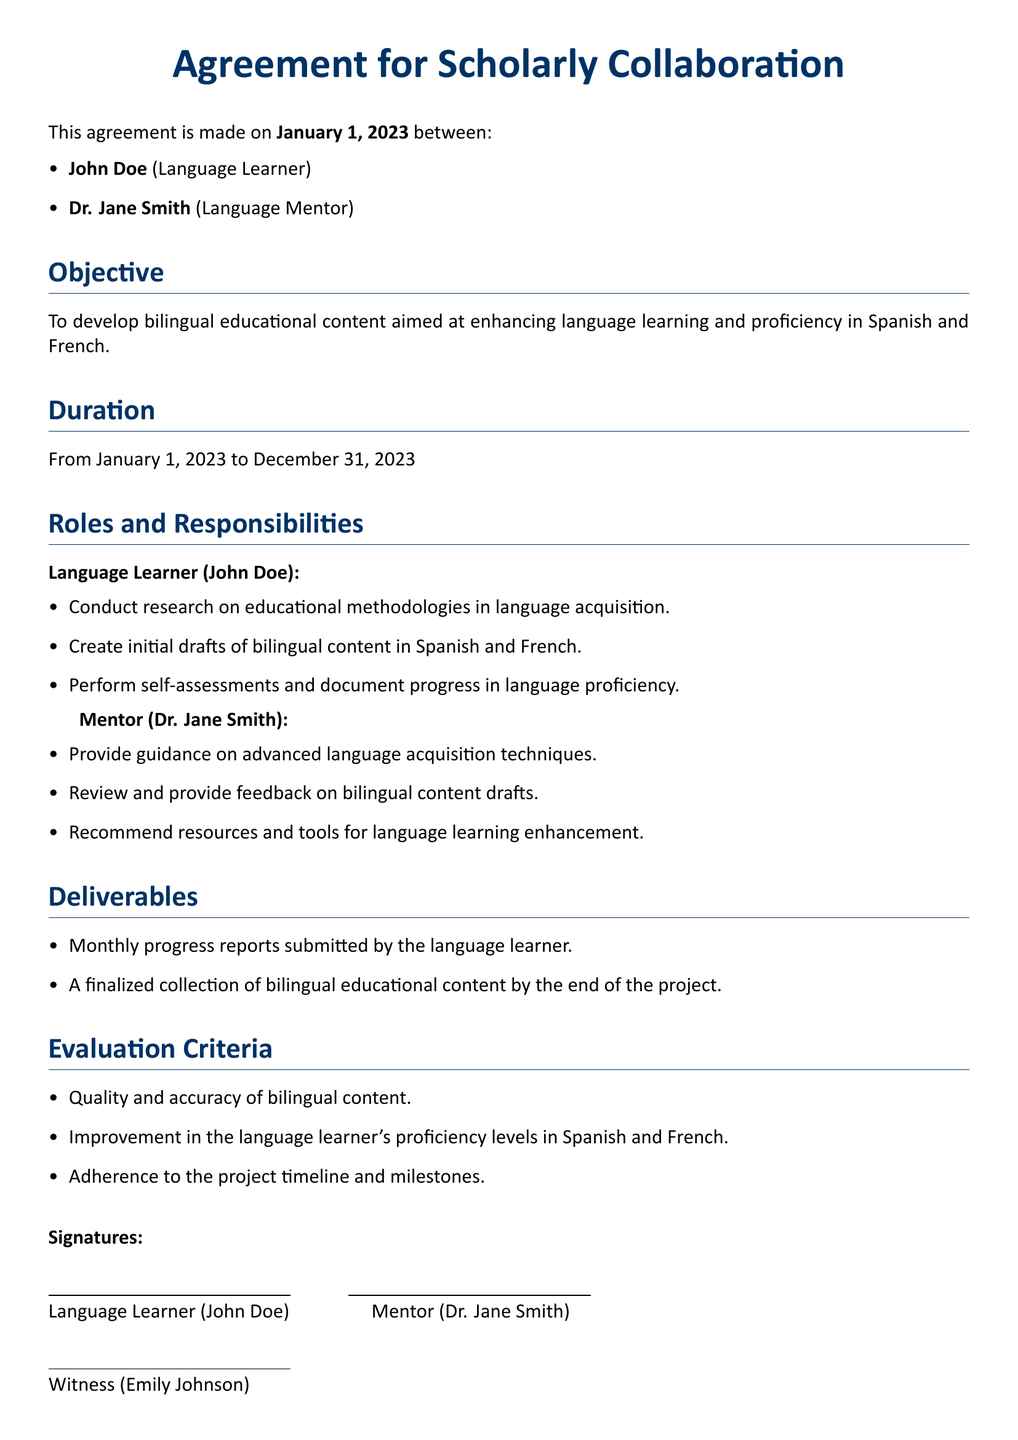What is the date the agreement was made? The date is clearly stated at the beginning of the document as January 1, 2023.
Answer: January 1, 2023 Who is the language mentor? The document lists Dr. Jane Smith as the language mentor in the introduction section.
Answer: Dr. Jane Smith What is the duration of the project? The duration is specified in the document, stating from January 1, 2023, to December 31, 2023.
Answer: January 1, 2023 to December 31, 2023 What is the primary objective of the agreement? The objective is stated explicitly as developing bilingual educational content aimed at enhancing language learning and proficiency in Spanish and French.
Answer: Developing bilingual educational content How many deliverables are mentioned? The document lists two deliverables that are specified in the Deliverables section.
Answer: Two What criteria is used for evaluation? The Evaluation Criteria section mentions three criteria for evaluation based on the quality and accuracy of content, improvement in proficiency levels, and adherence to the timeline.
Answer: Quality and accuracy of bilingual content Who is the witness? The witness is named at the end of the document, marking her involvement in the agreement.
Answer: Emily Johnson What is the role of the language learner? The document outlines specific responsibilities for the language learner, including conducting research and creating content drafts.
Answer: Conduct research on educational methodologies 